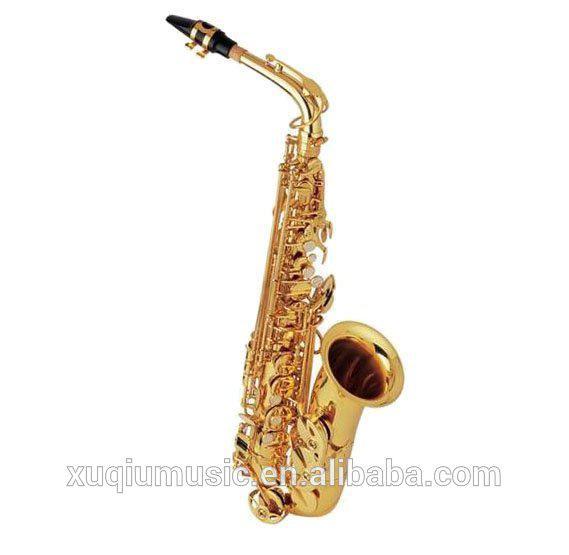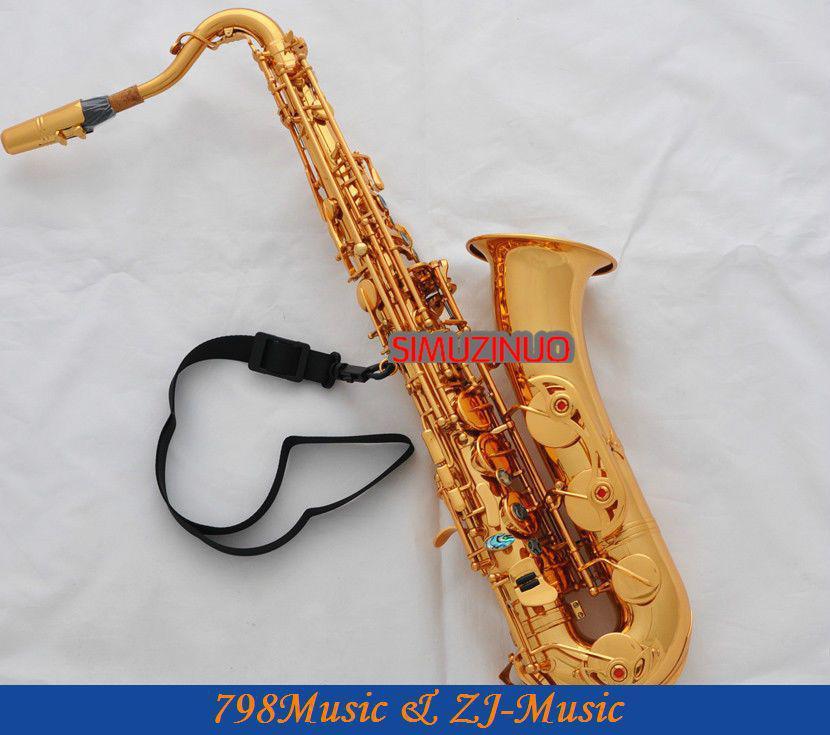The first image is the image on the left, the second image is the image on the right. For the images displayed, is the sentence "The left-hand instrument is vertical with a silver body." factually correct? Answer yes or no. No. 